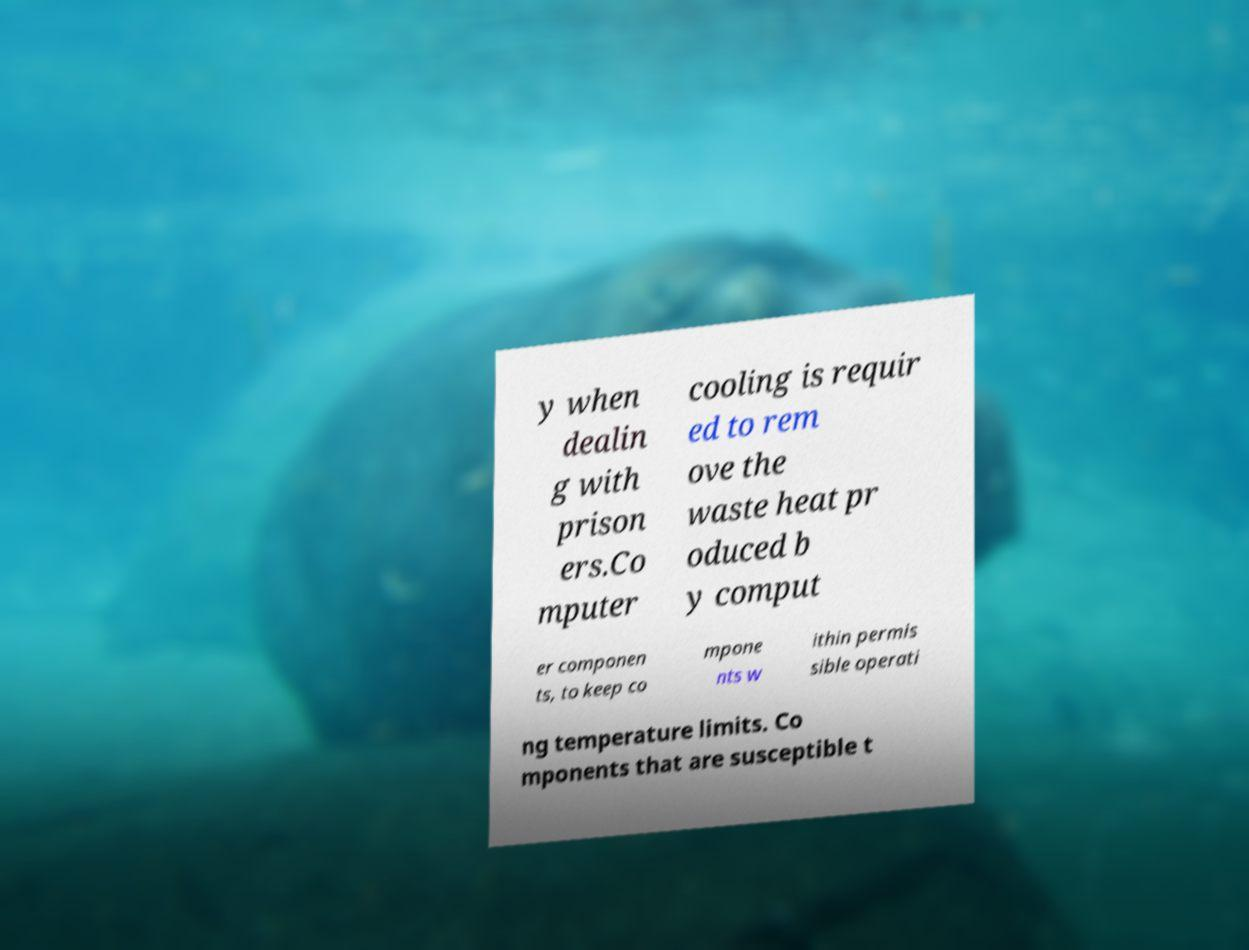For documentation purposes, I need the text within this image transcribed. Could you provide that? y when dealin g with prison ers.Co mputer cooling is requir ed to rem ove the waste heat pr oduced b y comput er componen ts, to keep co mpone nts w ithin permis sible operati ng temperature limits. Co mponents that are susceptible t 